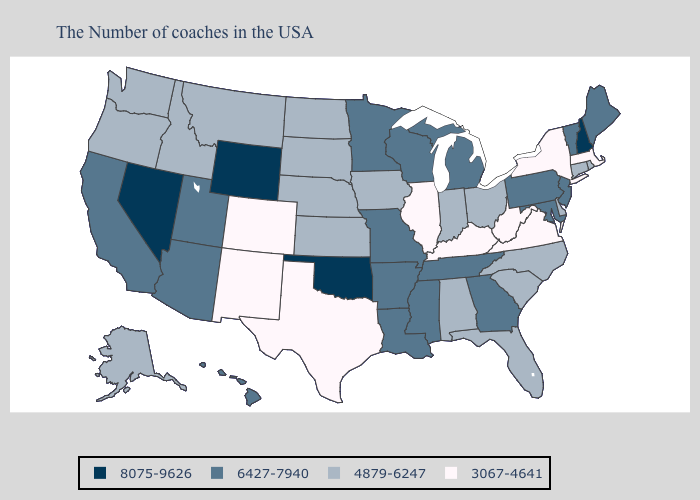Does South Dakota have a lower value than New York?
Write a very short answer. No. What is the highest value in states that border Arizona?
Give a very brief answer. 8075-9626. Which states have the lowest value in the MidWest?
Write a very short answer. Illinois. Which states have the lowest value in the USA?
Write a very short answer. Massachusetts, New York, Virginia, West Virginia, Kentucky, Illinois, Texas, Colorado, New Mexico. What is the highest value in states that border Nebraska?
Short answer required. 8075-9626. What is the lowest value in the South?
Concise answer only. 3067-4641. What is the value of Maine?
Concise answer only. 6427-7940. Does the first symbol in the legend represent the smallest category?
Answer briefly. No. What is the value of Colorado?
Write a very short answer. 3067-4641. Name the states that have a value in the range 4879-6247?
Give a very brief answer. Rhode Island, Connecticut, Delaware, North Carolina, South Carolina, Ohio, Florida, Indiana, Alabama, Iowa, Kansas, Nebraska, South Dakota, North Dakota, Montana, Idaho, Washington, Oregon, Alaska. Which states have the highest value in the USA?
Concise answer only. New Hampshire, Oklahoma, Wyoming, Nevada. Name the states that have a value in the range 3067-4641?
Give a very brief answer. Massachusetts, New York, Virginia, West Virginia, Kentucky, Illinois, Texas, Colorado, New Mexico. What is the highest value in the Northeast ?
Write a very short answer. 8075-9626. What is the value of South Dakota?
Keep it brief. 4879-6247. Which states have the lowest value in the MidWest?
Write a very short answer. Illinois. 